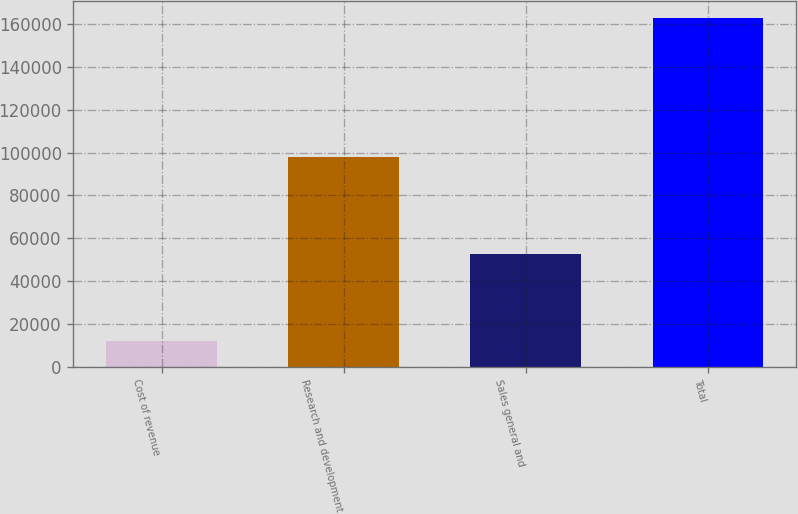Convert chart. <chart><loc_0><loc_0><loc_500><loc_500><bar_chart><fcel>Cost of revenue<fcel>Research and development<fcel>Sales general and<fcel>Total<nl><fcel>11939<fcel>98007<fcel>52760<fcel>162706<nl></chart> 